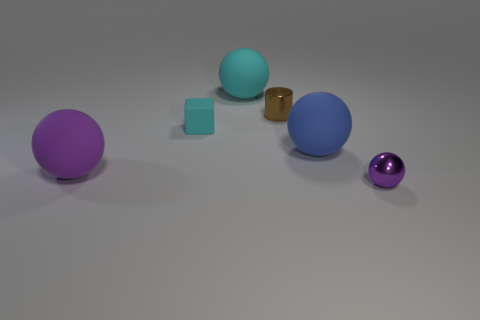Do the small metal thing to the left of the tiny purple metallic ball and the block have the same color?
Give a very brief answer. No. What material is the thing that is both in front of the blue matte object and behind the small ball?
Your response must be concise. Rubber. There is a big rubber object that is to the left of the large cyan matte object; is there a rubber cube that is on the right side of it?
Your response must be concise. Yes. Does the cyan cube have the same material as the big cyan thing?
Offer a very short reply. Yes. There is a object that is both to the left of the small brown cylinder and behind the tiny cyan block; what is its shape?
Your answer should be compact. Sphere. What is the size of the metallic thing that is behind the purple sphere that is to the left of the brown metal thing?
Your answer should be very brief. Small. What number of small cyan objects are the same shape as the blue thing?
Give a very brief answer. 0. Does the block have the same color as the small ball?
Offer a very short reply. No. Is there any other thing that is the same shape as the tiny cyan object?
Your answer should be compact. No. Is there another ball of the same color as the small metal ball?
Provide a succinct answer. Yes. 